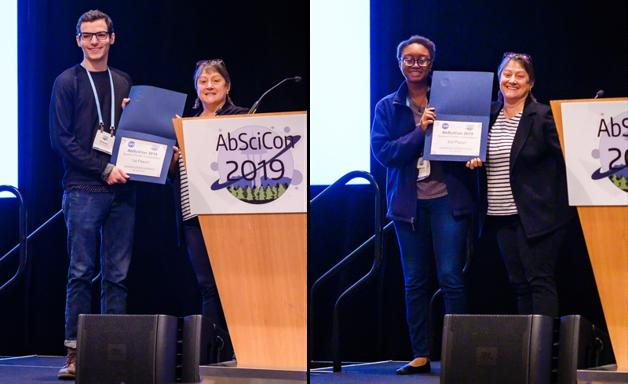What can you infer about the significance of these awards in the scientific community? Such awards play a crucial role in the scientific community by recognizing and incentivizing groundbreaking research and achievements. They not only honor individual accomplishments but also inspire ongoing commitment and passion for advancing the understanding of life's potential across the universe. How do you think these awards might impact the careers of the recipients? Receiving these awards likely boosts the recipients' professional visibility and credibility, opens up new opportunities for collaboration and research, and perhaps enhances their influence in the academic and research communities. 